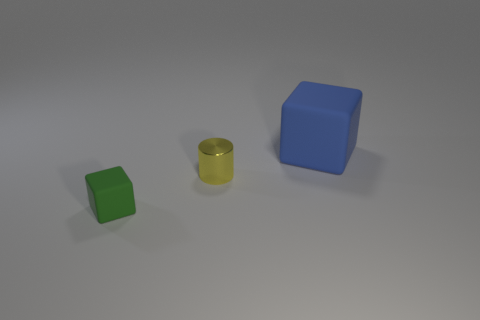What material is the other big object that is the same shape as the green matte thing?
Provide a short and direct response. Rubber. What number of red blocks have the same size as the metallic thing?
Ensure brevity in your answer.  0. What color is the thing that is to the left of the large blue object and right of the small green matte object?
Offer a very short reply. Yellow. Are there fewer shiny cylinders than red blocks?
Provide a short and direct response. No. Is the color of the big object the same as the small object that is in front of the yellow metallic cylinder?
Make the answer very short. No. Are there the same number of objects that are right of the tiny green matte thing and objects that are in front of the blue rubber object?
Your answer should be very brief. Yes. How many large objects have the same shape as the tiny green thing?
Your answer should be compact. 1. Are any tiny cyan blocks visible?
Ensure brevity in your answer.  No. Do the big blue thing and the cube in front of the small metallic cylinder have the same material?
Ensure brevity in your answer.  Yes. There is a green cube that is the same size as the yellow object; what is it made of?
Give a very brief answer. Rubber. 